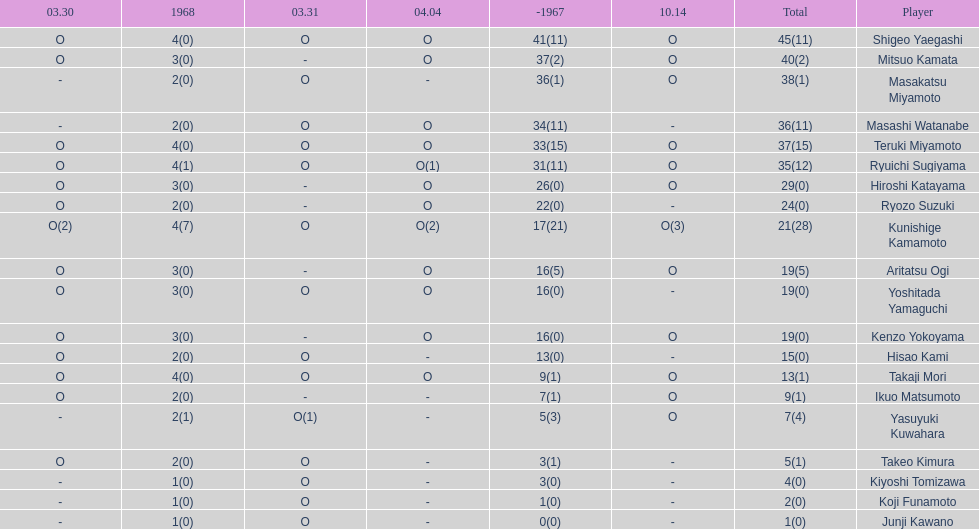Who had more points takaji mori or junji kawano? Takaji Mori. 